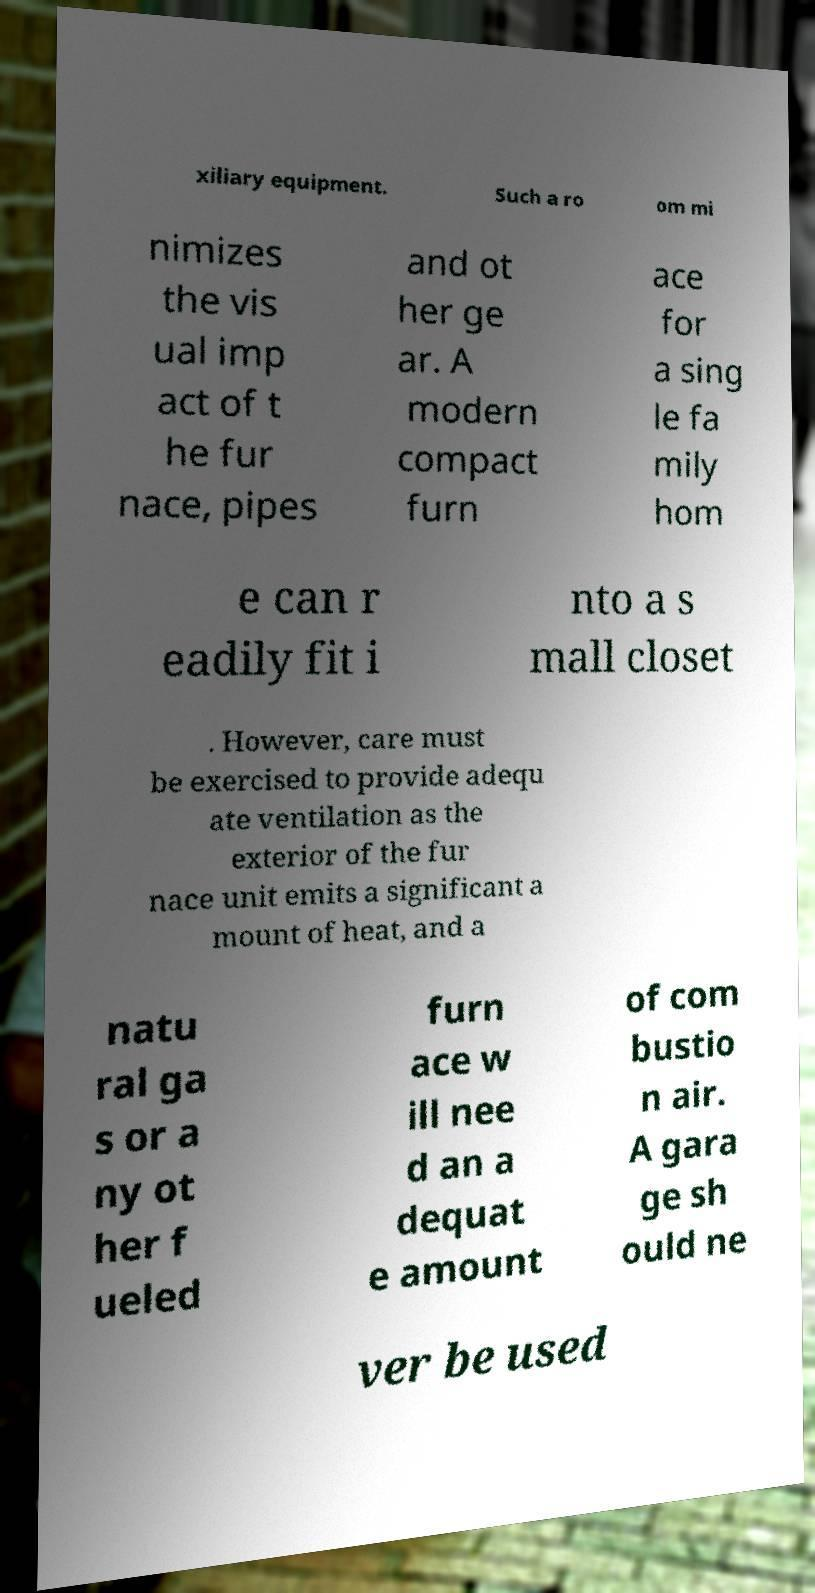For documentation purposes, I need the text within this image transcribed. Could you provide that? xiliary equipment. Such a ro om mi nimizes the vis ual imp act of t he fur nace, pipes and ot her ge ar. A modern compact furn ace for a sing le fa mily hom e can r eadily fit i nto a s mall closet . However, care must be exercised to provide adequ ate ventilation as the exterior of the fur nace unit emits a significant a mount of heat, and a natu ral ga s or a ny ot her f ueled furn ace w ill nee d an a dequat e amount of com bustio n air. A gara ge sh ould ne ver be used 